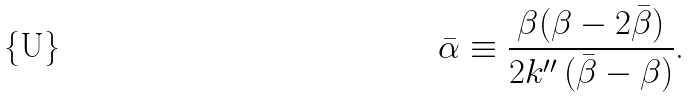<formula> <loc_0><loc_0><loc_500><loc_500>\bar { \alpha } \equiv \frac { \beta ( \beta - 2 \bar { \beta } ) } { 2 k ^ { \prime \prime } \, ( \bar { \beta } - \beta ) } \text {.}</formula> 